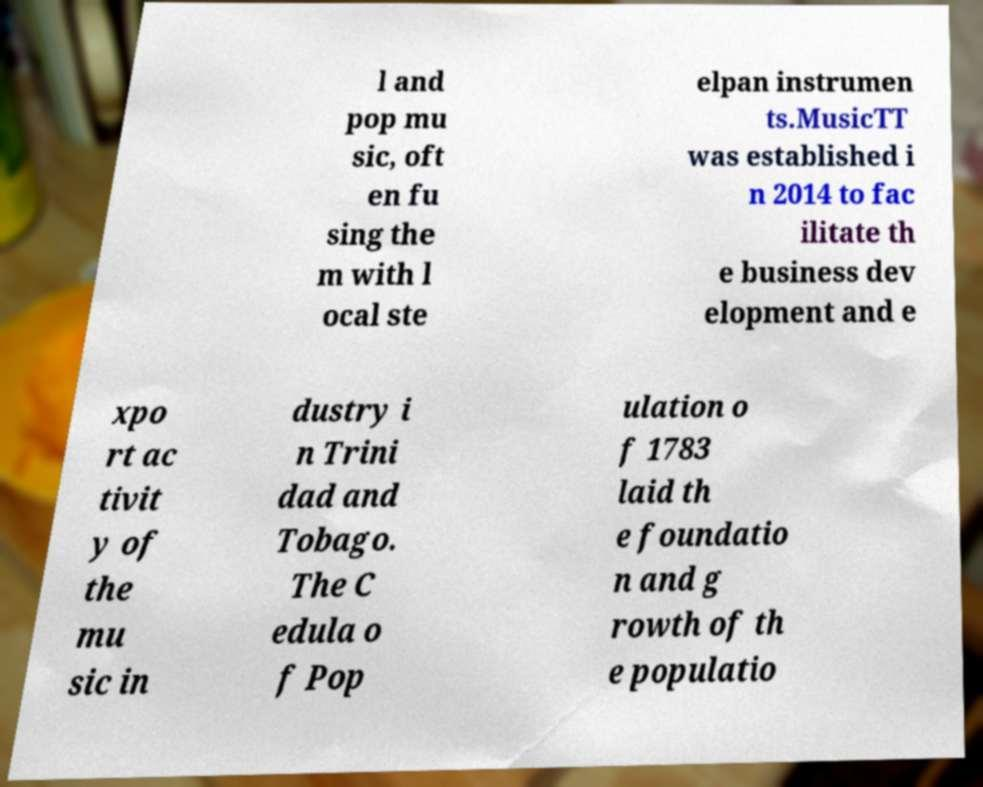There's text embedded in this image that I need extracted. Can you transcribe it verbatim? l and pop mu sic, oft en fu sing the m with l ocal ste elpan instrumen ts.MusicTT was established i n 2014 to fac ilitate th e business dev elopment and e xpo rt ac tivit y of the mu sic in dustry i n Trini dad and Tobago. The C edula o f Pop ulation o f 1783 laid th e foundatio n and g rowth of th e populatio 